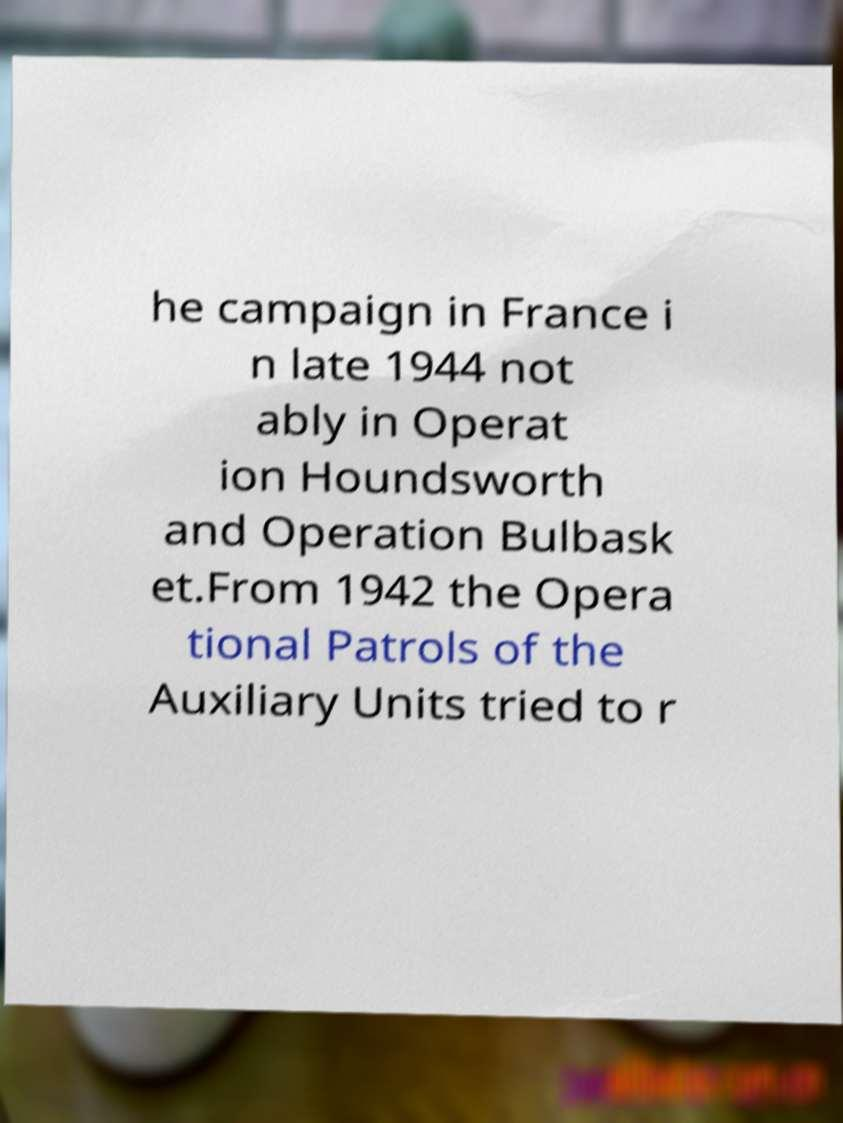Can you accurately transcribe the text from the provided image for me? he campaign in France i n late 1944 not ably in Operat ion Houndsworth and Operation Bulbask et.From 1942 the Opera tional Patrols of the Auxiliary Units tried to r 